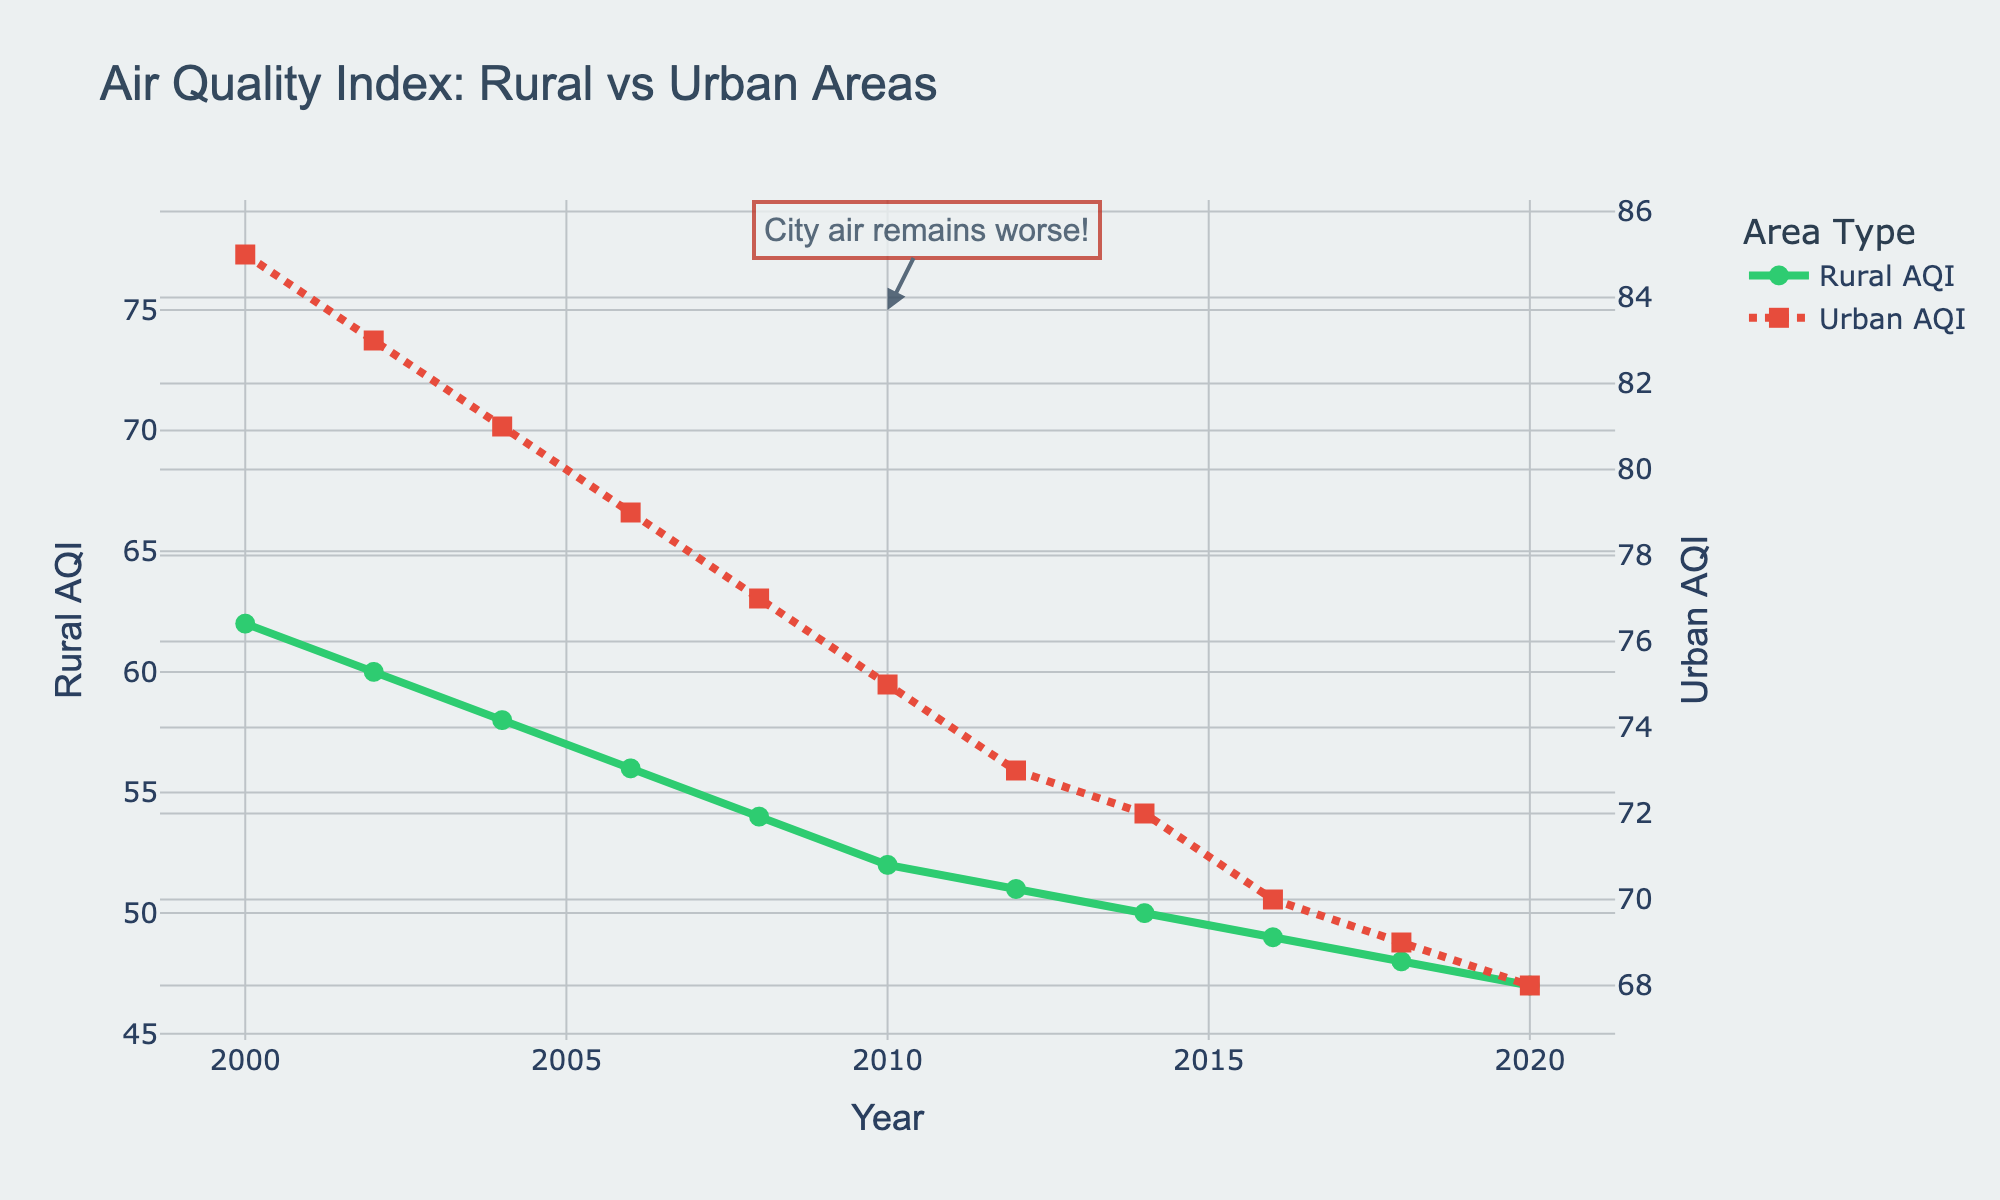What is the trend for the Rural AQI over the past two decades? The Rural AQI shows a consistent decreasing trend from 62 in the year 2000 to 47 in the year 2020.
Answer: Decreasing Is the Urban AQI always higher than the Rural AQI throughout the given period? Yes, by examining the graph, it is clear that the Urban AQI values are consistently higher than the Rural AQI values for each year from 2000 to 2020.
Answer: Yes What is the difference in Rural AQI between the years 2000 and 2020? To find the difference, subtract the Rural AQI of 2020 from the Rural AQI of 2000: 62 - 47 = 15.
Answer: 15 Which year has the smallest urban AQI and what is its value? The smallest Urban AQI occurs in the year 2020, with a value of 68 as observed from the chart.
Answer: 2020, 68 By how much did the Urban AQI decrease from 2000 to 2010? To calculate the decrease, subtract the Urban AQI of 2010 from that of 2000: 85 - 75 = 10.
Answer: 10 What is the pattern of the Urban AQI value change as compared to Rural AQI? Both the Urban AQI and the Rural AQI show a decreasing trend over the two decades, though the Urban AQI is consistently higher.
Answer: Decreasing, Urban higher If you average the AQI values for Rural and Urban areas for the decade 2000-2010, which one has a lower average? First, calculate the average AQI values:
Rural: (62 + 60 + 58 + 56 + 54 + 52)/6 = 57
Urban: (85 + 83 + 81 + 79 + 77 + 75)/6 = 80
The Rural average is lower than the Urban average.
Answer: Rural What visual attribute distinguishes the two datasets in the graph? The graph uses two different line styles and markers: the Rural AQI is represented by a continuous green line with circles, while the Urban AQI is shown by a red dotted line with squares.
Answer: Line styles and markers By how much did the Rural AQI improve from 2002 to 2010? To find the improvement, subtract the Rural AQI of 2010 from that of 2002: 60 - 52 = 8.
Answer: 8 